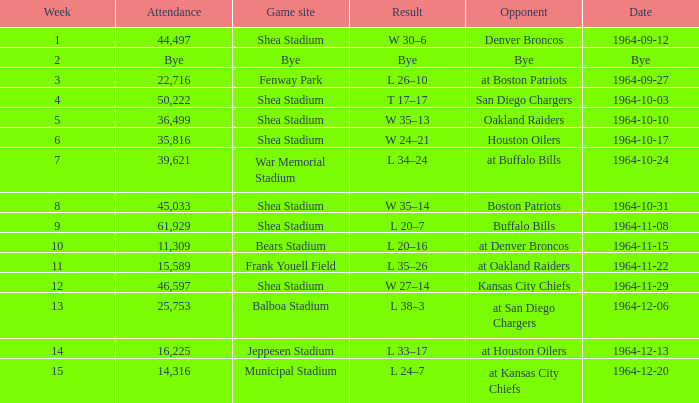Could you parse the entire table as a dict? {'header': ['Week', 'Attendance', 'Game site', 'Result', 'Opponent', 'Date'], 'rows': [['1', '44,497', 'Shea Stadium', 'W 30–6', 'Denver Broncos', '1964-09-12'], ['2', 'Bye', 'Bye', 'Bye', 'Bye', 'Bye'], ['3', '22,716', 'Fenway Park', 'L 26–10', 'at Boston Patriots', '1964-09-27'], ['4', '50,222', 'Shea Stadium', 'T 17–17', 'San Diego Chargers', '1964-10-03'], ['5', '36,499', 'Shea Stadium', 'W 35–13', 'Oakland Raiders', '1964-10-10'], ['6', '35,816', 'Shea Stadium', 'W 24–21', 'Houston Oilers', '1964-10-17'], ['7', '39,621', 'War Memorial Stadium', 'L 34–24', 'at Buffalo Bills', '1964-10-24'], ['8', '45,033', 'Shea Stadium', 'W 35–14', 'Boston Patriots', '1964-10-31'], ['9', '61,929', 'Shea Stadium', 'L 20–7', 'Buffalo Bills', '1964-11-08'], ['10', '11,309', 'Bears Stadium', 'L 20–16', 'at Denver Broncos', '1964-11-15'], ['11', '15,589', 'Frank Youell Field', 'L 35–26', 'at Oakland Raiders', '1964-11-22'], ['12', '46,597', 'Shea Stadium', 'W 27–14', 'Kansas City Chiefs', '1964-11-29'], ['13', '25,753', 'Balboa Stadium', 'L 38–3', 'at San Diego Chargers', '1964-12-06'], ['14', '16,225', 'Jeppesen Stadium', 'L 33–17', 'at Houston Oilers', '1964-12-13'], ['15', '14,316', 'Municipal Stadium', 'L 24–7', 'at Kansas City Chiefs', '1964-12-20']]} What's the result of the game against Bye? Bye. 